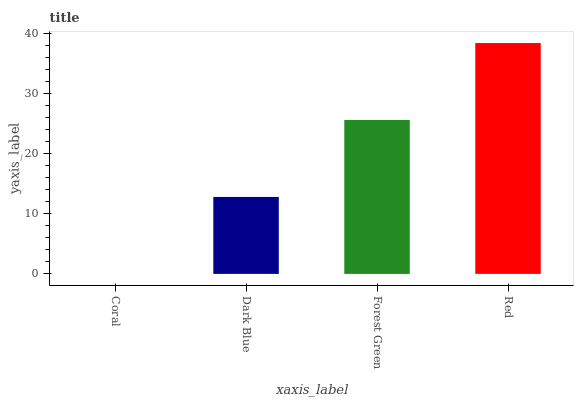Is Coral the minimum?
Answer yes or no. Yes. Is Red the maximum?
Answer yes or no. Yes. Is Dark Blue the minimum?
Answer yes or no. No. Is Dark Blue the maximum?
Answer yes or no. No. Is Dark Blue greater than Coral?
Answer yes or no. Yes. Is Coral less than Dark Blue?
Answer yes or no. Yes. Is Coral greater than Dark Blue?
Answer yes or no. No. Is Dark Blue less than Coral?
Answer yes or no. No. Is Forest Green the high median?
Answer yes or no. Yes. Is Dark Blue the low median?
Answer yes or no. Yes. Is Red the high median?
Answer yes or no. No. Is Forest Green the low median?
Answer yes or no. No. 